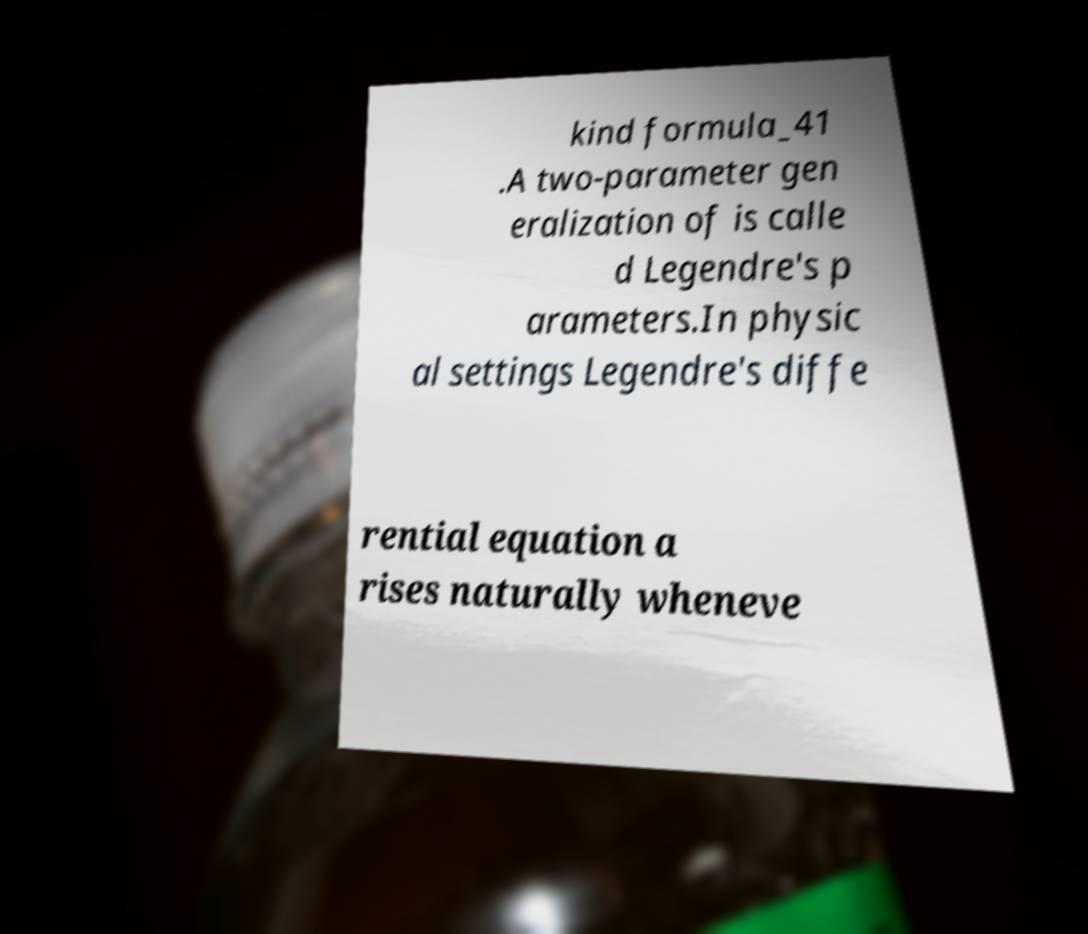What messages or text are displayed in this image? I need them in a readable, typed format. kind formula_41 .A two-parameter gen eralization of is calle d Legendre's p arameters.In physic al settings Legendre's diffe rential equation a rises naturally wheneve 